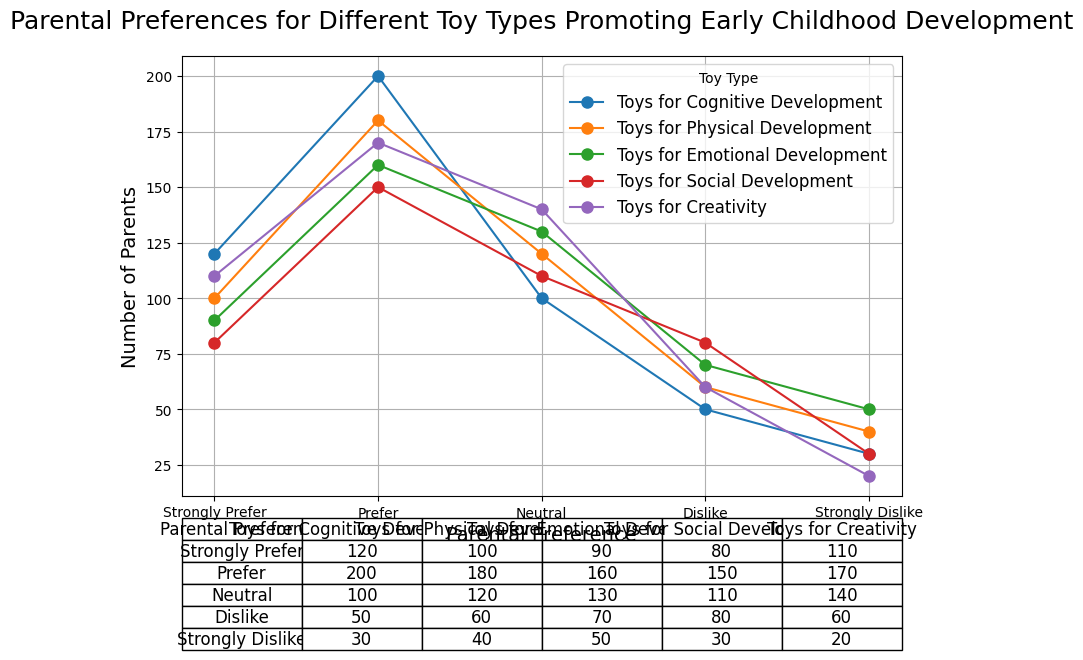Which toy type has the highest number of parents strongly preferring it? To find this, look at the 'Strongly Prefer' row and identify the highest value among all toy types. The highest value in the 'Strongly Prefer' row is 120 under 'Toys for Cognitive Development'.
Answer: Toys for Cognitive Development Which parental preference category has the most variation among the toy types? To determine variation, observe the range of values within each preference category. The 'Neutral' category ranges from 100 to 140, showing the most variation (40).
Answer: Neutral How many more parents prefer toys for cognitive development over social development? Compare the 'Prefer' column values for these two categories: 200 (Cognitive) and 150 (Social). Calculate the difference: 200 - 150.
Answer: 50 Which toy type is most commonly disliked by parents? Look at the 'Dislike' row and identify the highest number. The 'Dislike' row shows 80 under 'Toys for Social Development' as the highest.
Answer: Toys for Social Development For parents who are neutral, what’s the difference between the most and least favored toy type? Identify the highest and lowest values in the 'Neutral' row: 140 (Creativity) and 100 (Cognitive). Calculate the difference: 140 - 100.
Answer: 40 Which toy category sees equal numbers of parents with strong preference and neutral stance? Compare the values in the 'Strongly Prefer' and 'Neutral' rows. Both have 100 for 'Toys for Physical Development'.
Answer: Toys for Physical Development Do more parents strongly dislike toys for emotional development or toys for creativity? Compare the 'Strongly Dislike' values: 50 (Emotional) and 20 (Creativity).
Answer: Toys for Emotional Development What is the total number of parents who either prefer or strongly prefer toys for creativity? Sum the values in 'Prefer' and 'Strongly Prefer' columns for Creativity: 170 + 110.
Answer: 280 Which parental preference category has the least overall interest across all toy types? Sum each row: 'Strongly Prefer' (500), 'Prefer' (860), 'Neutral' (600), 'Dislike' (320), 'Strongly Dislike' (170). The 'Strongly Dislike' category is the lowest.
Answer: Strongly Dislike 